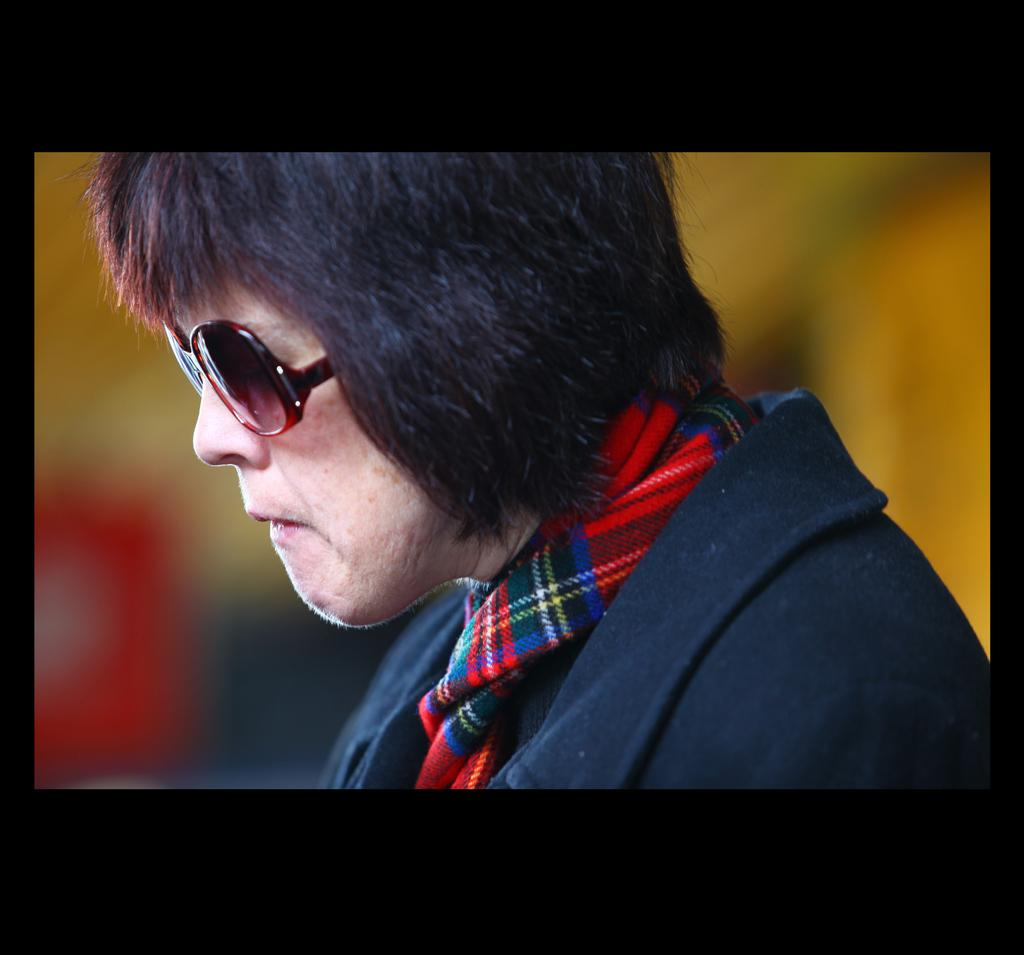What is the main subject of the image? There is a human in the image. What protective gear is the human wearing? The human is wearing goggles, a scarf, and a jacket. What can be observed about the background of the image? The background of the image is blurred. What is the color of the image's borders? The borders of the image are black. What arithmetic problem is the person solving in the image? There is no arithmetic problem visible in the image. How many icicles are hanging from the person's scarf in the image? There are no icicles present in the image. 